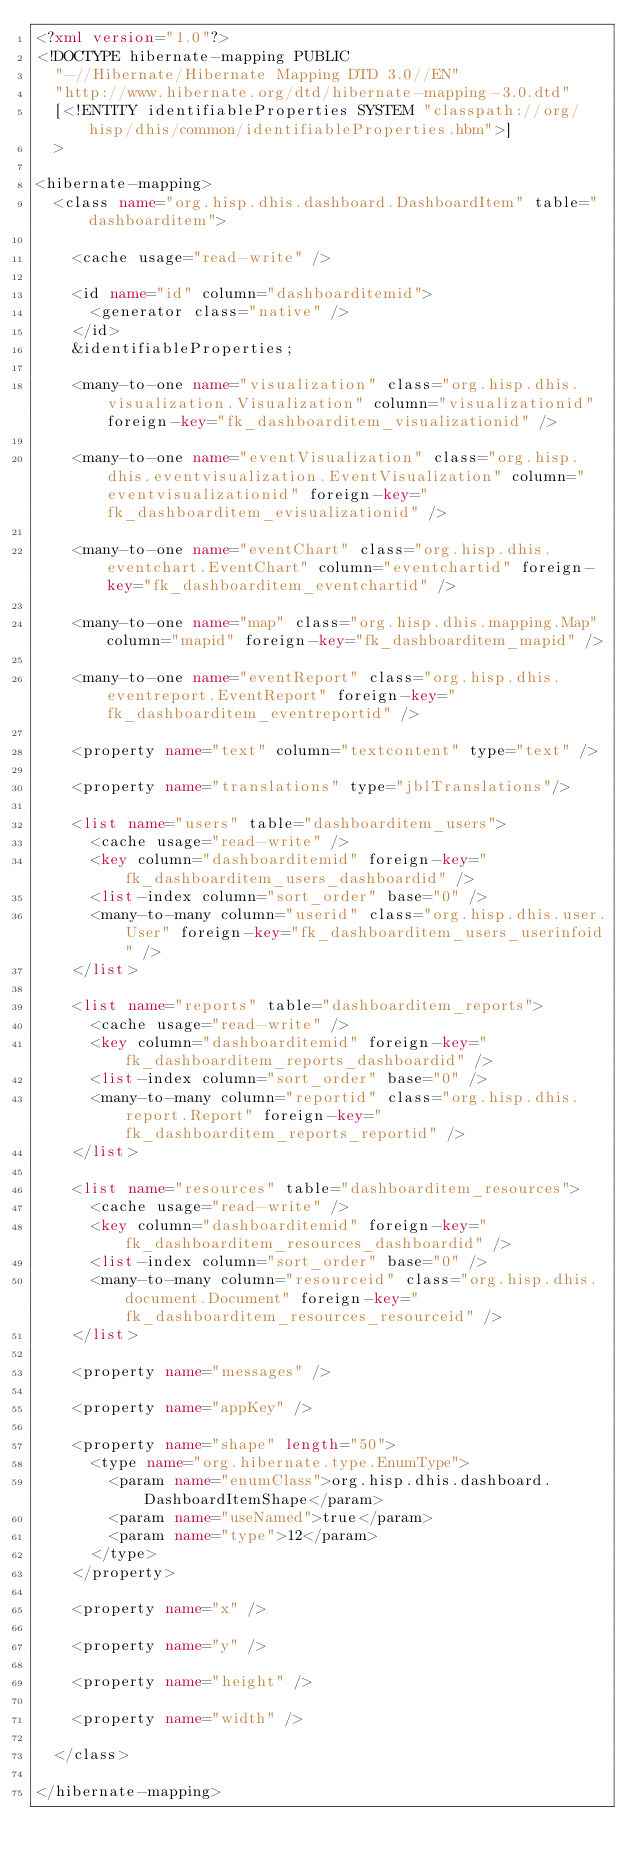Convert code to text. <code><loc_0><loc_0><loc_500><loc_500><_XML_><?xml version="1.0"?>
<!DOCTYPE hibernate-mapping PUBLIC
  "-//Hibernate/Hibernate Mapping DTD 3.0//EN"
  "http://www.hibernate.org/dtd/hibernate-mapping-3.0.dtd"
  [<!ENTITY identifiableProperties SYSTEM "classpath://org/hisp/dhis/common/identifiableProperties.hbm">]
  >

<hibernate-mapping>
  <class name="org.hisp.dhis.dashboard.DashboardItem" table="dashboarditem">

    <cache usage="read-write" />

    <id name="id" column="dashboarditemid">
      <generator class="native" />
    </id>
    &identifiableProperties;

    <many-to-one name="visualization" class="org.hisp.dhis.visualization.Visualization" column="visualizationid" foreign-key="fk_dashboarditem_visualizationid" />

    <many-to-one name="eventVisualization" class="org.hisp.dhis.eventvisualization.EventVisualization" column="eventvisualizationid" foreign-key="fk_dashboarditem_evisualizationid" />

    <many-to-one name="eventChart" class="org.hisp.dhis.eventchart.EventChart" column="eventchartid" foreign-key="fk_dashboarditem_eventchartid" />
    
    <many-to-one name="map" class="org.hisp.dhis.mapping.Map" column="mapid" foreign-key="fk_dashboarditem_mapid" />

    <many-to-one name="eventReport" class="org.hisp.dhis.eventreport.EventReport" foreign-key="fk_dashboarditem_eventreportid" />
    
    <property name="text" column="textcontent" type="text" />

    <property name="translations" type="jblTranslations"/>

    <list name="users" table="dashboarditem_users">
      <cache usage="read-write" />
      <key column="dashboarditemid" foreign-key="fk_dashboarditem_users_dashboardid" />
      <list-index column="sort_order" base="0" />
      <many-to-many column="userid" class="org.hisp.dhis.user.User" foreign-key="fk_dashboarditem_users_userinfoid" />
    </list>
    
    <list name="reports" table="dashboarditem_reports">
      <cache usage="read-write" />
      <key column="dashboarditemid" foreign-key="fk_dashboarditem_reports_dashboardid" />
      <list-index column="sort_order" base="0" />
      <many-to-many column="reportid" class="org.hisp.dhis.report.Report" foreign-key="fk_dashboarditem_reports_reportid" />
    </list>
 	
    <list name="resources" table="dashboarditem_resources">
      <cache usage="read-write" />
      <key column="dashboarditemid" foreign-key="fk_dashboarditem_resources_dashboardid" />
      <list-index column="sort_order" base="0" />
      <many-to-many column="resourceid" class="org.hisp.dhis.document.Document" foreign-key="fk_dashboarditem_resources_resourceid" />
    </list>

    <property name="messages" />

    <property name="appKey" />

    <property name="shape" length="50">
      <type name="org.hibernate.type.EnumType">
        <param name="enumClass">org.hisp.dhis.dashboard.DashboardItemShape</param>
        <param name="useNamed">true</param>
        <param name="type">12</param>
      </type>
    </property>
    
    <property name="x" />
    
    <property name="y" />
    
    <property name="height" />
    
    <property name="width" />

  </class>

</hibernate-mapping>
</code> 